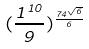<formula> <loc_0><loc_0><loc_500><loc_500>( \frac { 1 ^ { 1 0 } } { 9 } ) ^ { \frac { 7 4 ^ { \sqrt { 6 } } } { 6 } }</formula> 